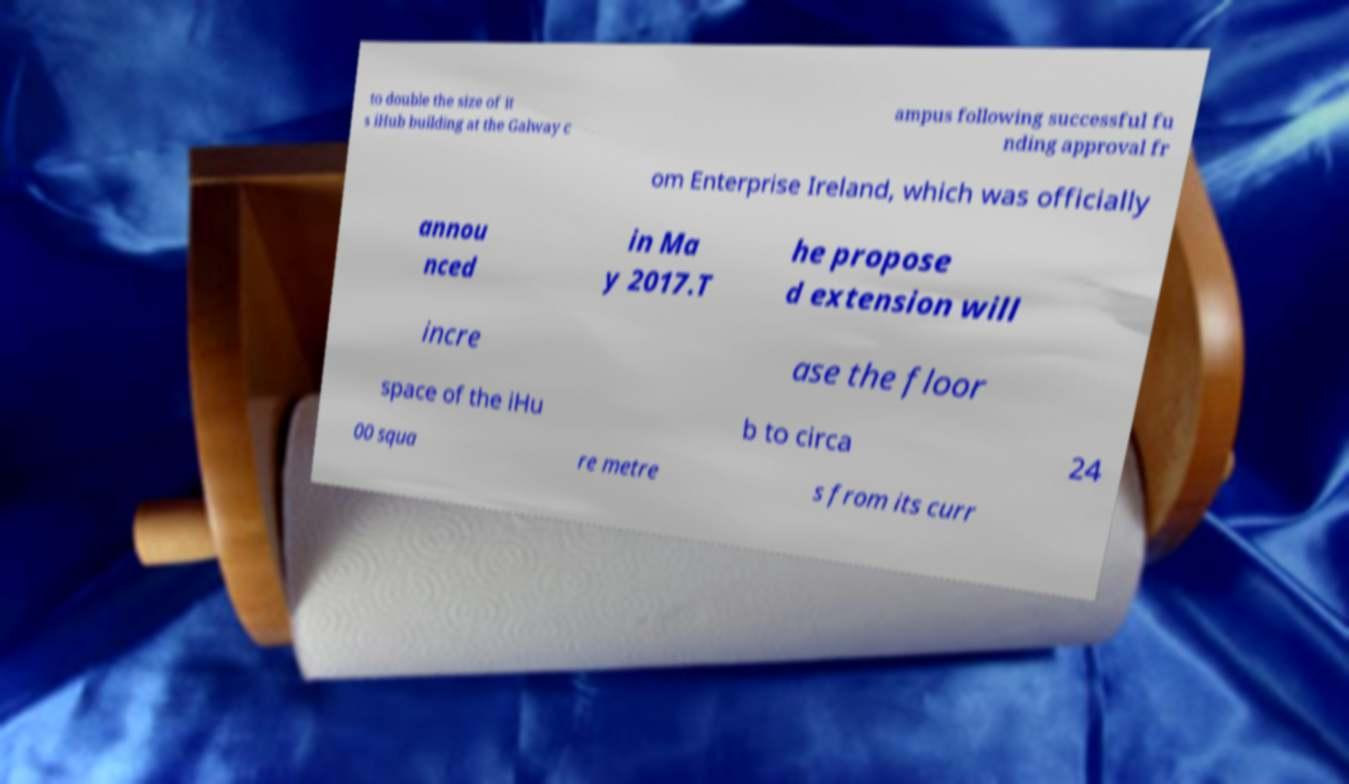Can you read and provide the text displayed in the image?This photo seems to have some interesting text. Can you extract and type it out for me? to double the size of it s iHub building at the Galway c ampus following successful fu nding approval fr om Enterprise Ireland, which was officially annou nced in Ma y 2017.T he propose d extension will incre ase the floor space of the iHu b to circa 24 00 squa re metre s from its curr 